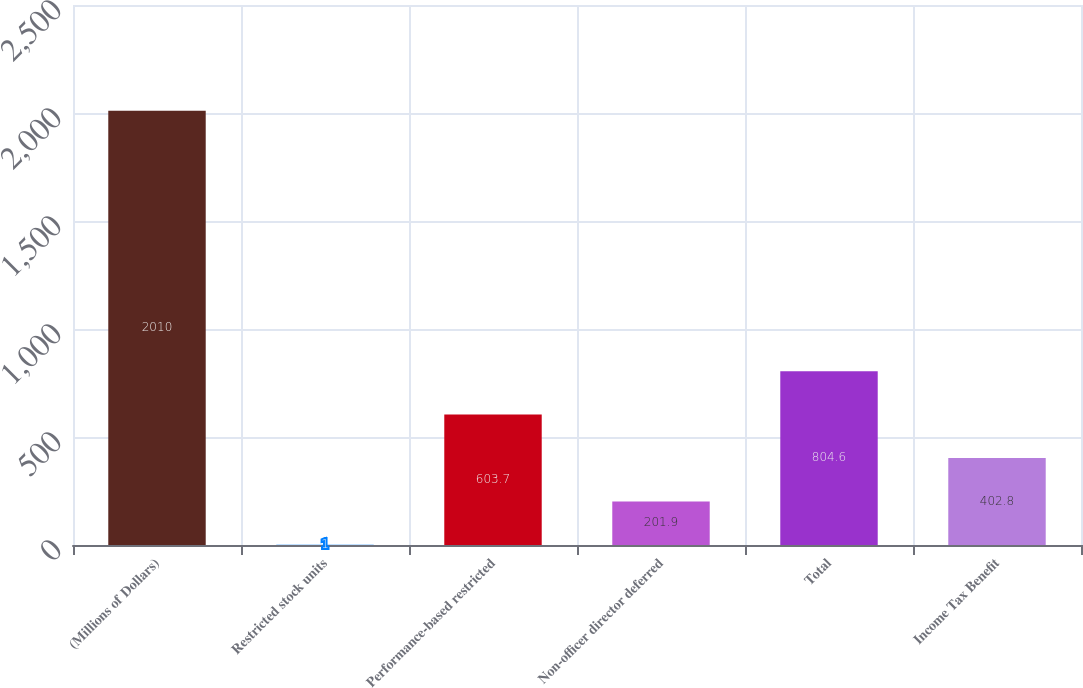<chart> <loc_0><loc_0><loc_500><loc_500><bar_chart><fcel>(Millions of Dollars)<fcel>Restricted stock units<fcel>Performance-based restricted<fcel>Non-officer director deferred<fcel>Total<fcel>Income Tax Benefit<nl><fcel>2010<fcel>1<fcel>603.7<fcel>201.9<fcel>804.6<fcel>402.8<nl></chart> 